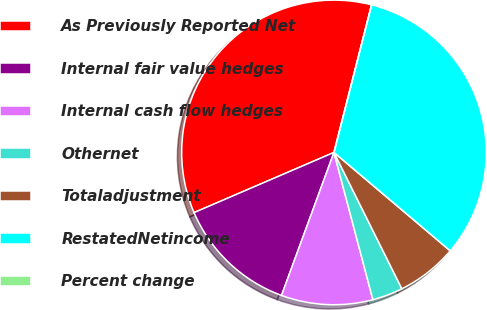Convert chart to OTSL. <chart><loc_0><loc_0><loc_500><loc_500><pie_chart><fcel>As Previously Reported Net<fcel>Internal fair value hedges<fcel>Internal cash flow hedges<fcel>Othernet<fcel>Totaladjustment<fcel>RestatedNetincome<fcel>Percent change<nl><fcel>35.44%<fcel>12.94%<fcel>9.71%<fcel>3.24%<fcel>6.47%<fcel>32.21%<fcel>0.0%<nl></chart> 